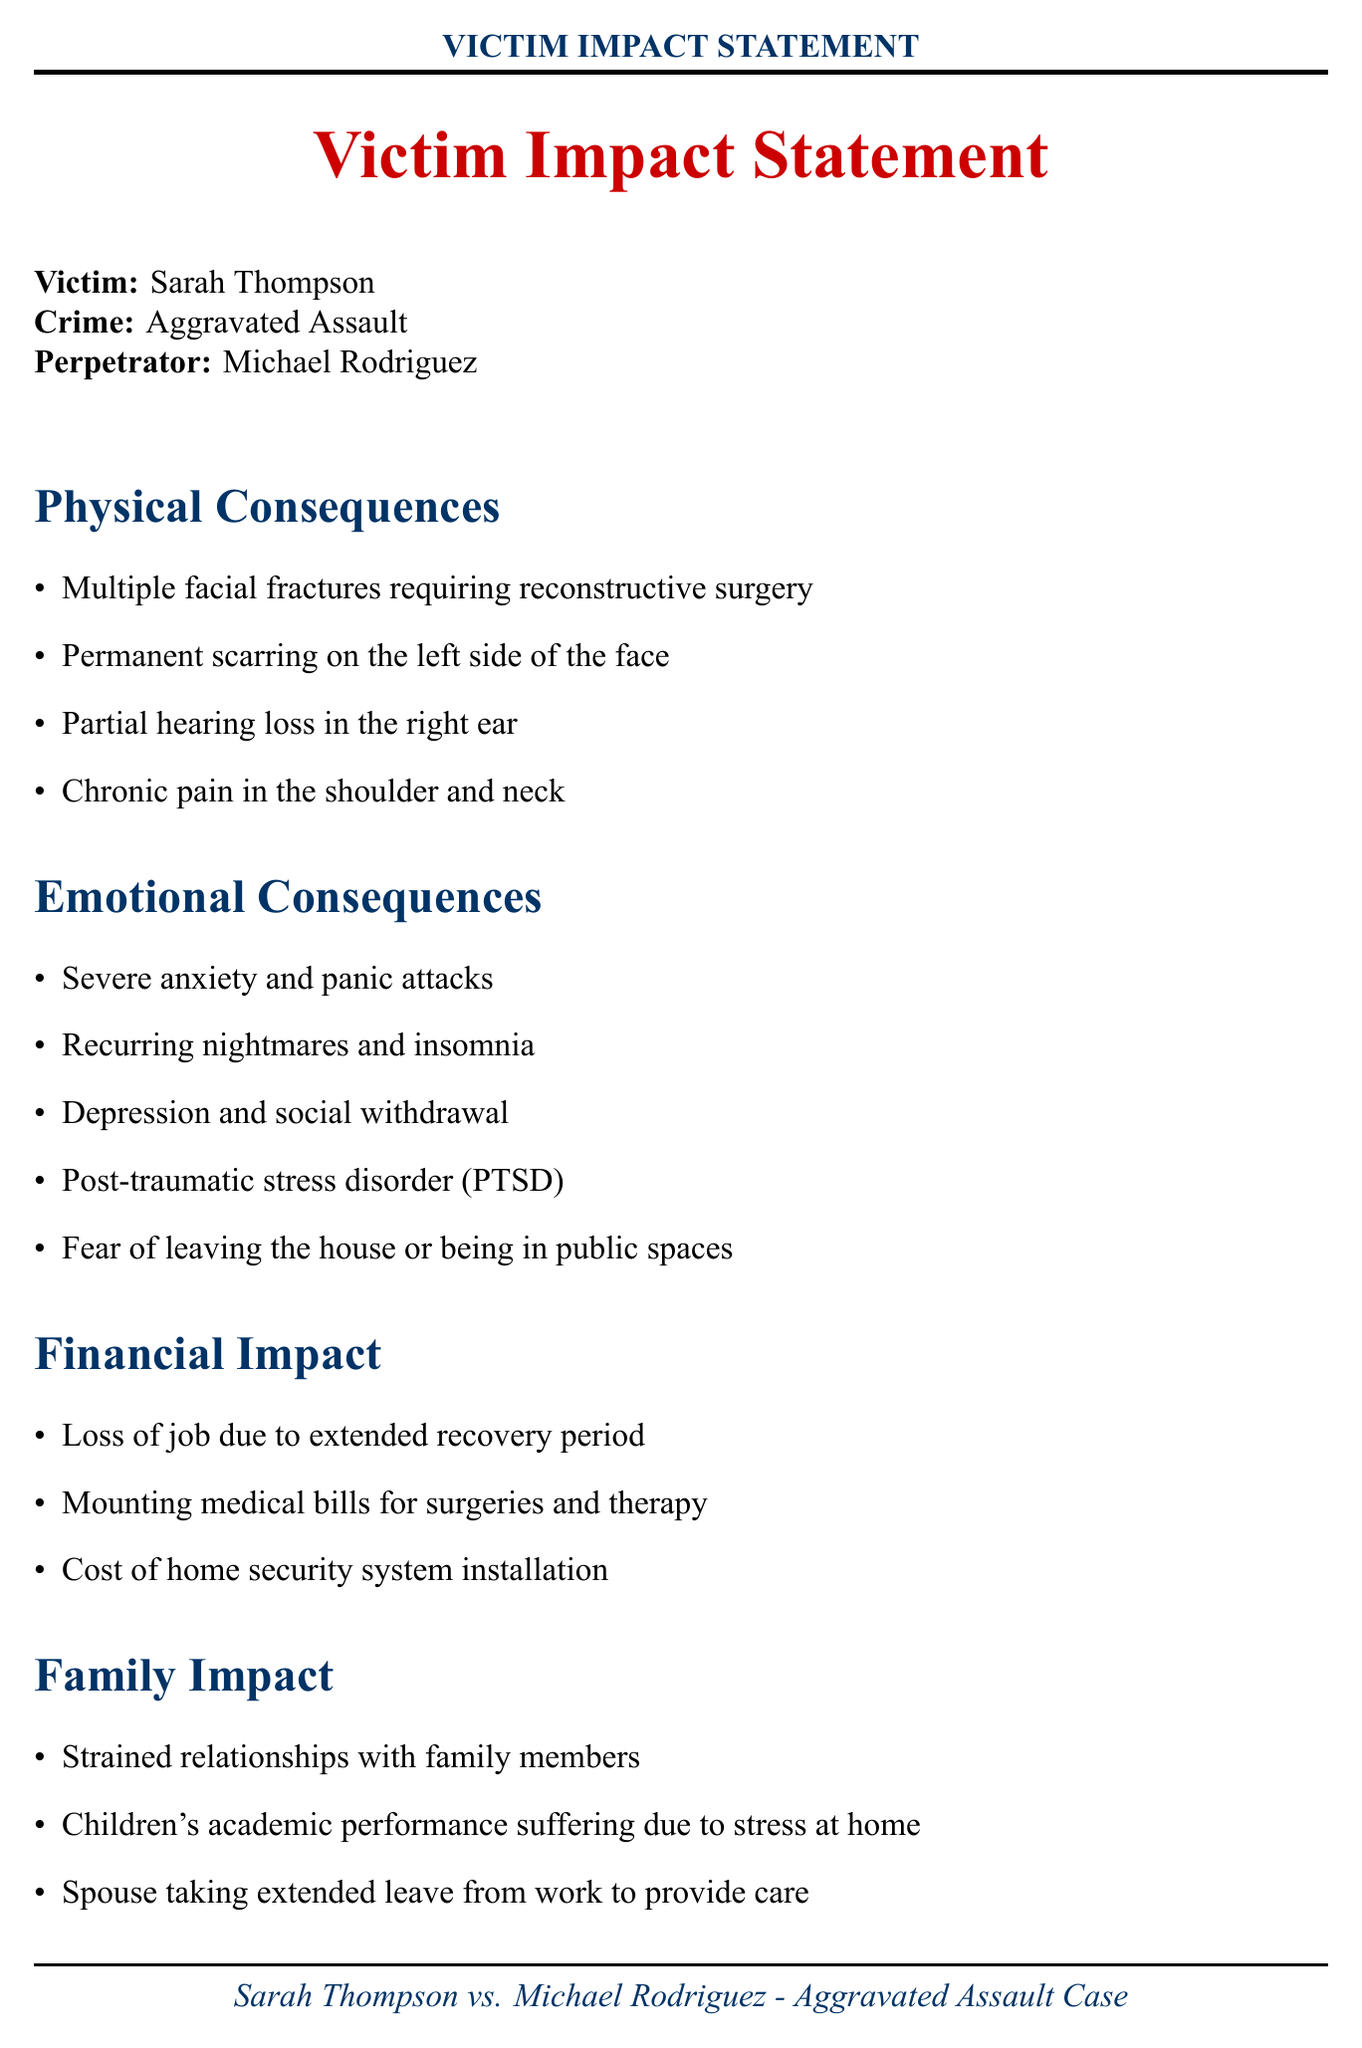What is the name of the victim? The victim's name is stated at the beginning of the document.
Answer: Sarah Thompson Who is the perpetrator of the crime? The perpetrator's name is listed alongside the victim and crime details.
Answer: Michael Rodriguez What type of crime was committed? The crime type is mentioned clearly in the document's introductory section.
Answer: Aggravated Assault How many physical consequences are listed? The number of physical consequences can be counted from the list provided in the document.
Answer: Four What emotional consequence includes fear of public spaces? This emotional consequence is specified among the list of emotional impacts described.
Answer: Fear of leaving the house or being in public spaces What financial impact resulted from job loss? The financial impact associated with job loss is detailed in the document.
Answer: Loss of job due to extended recovery period What community impact is mentioned related to local businesses? This community impact is specified in relation to businesses in the neighborhood.
Answer: Local businesses reporting decreased foot traffic What does the victim participate in for support? Participation in a specific initiative is mentioned as a form of resilience in the document.
Answer: Support groups for assault survivors What is one emotional consequence that indicates a mental health issue? This consequence indicates a specific mental health condition associated with emotional trauma.
Answer: Post-traumatic stress disorder (PTSD) 